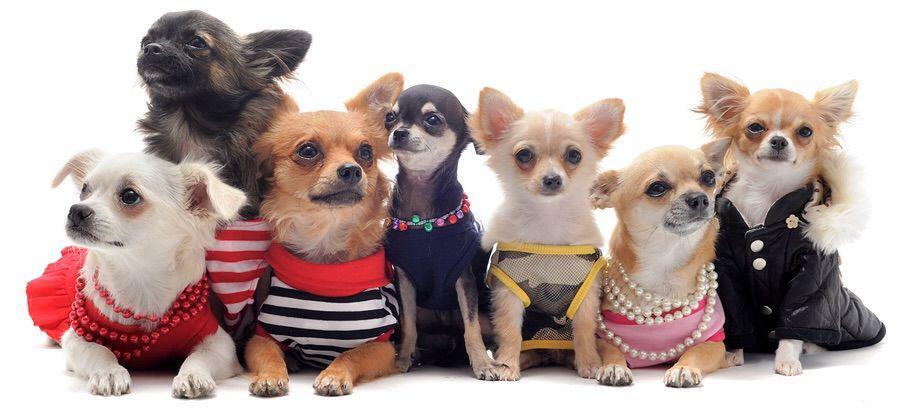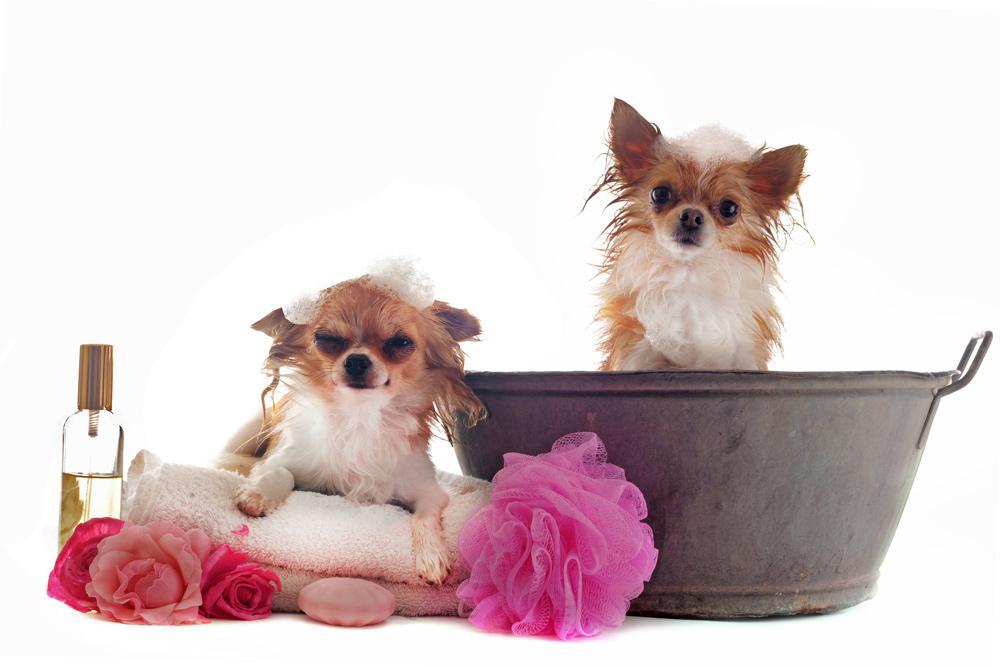The first image is the image on the left, the second image is the image on the right. For the images shown, is this caption "In one image, a very small dog is inside of a teacup" true? Answer yes or no. No. The first image is the image on the left, the second image is the image on the right. Analyze the images presented: Is the assertion "The left image contains at least three chihuahuas sitting in a horizontal row." valid? Answer yes or no. Yes. 